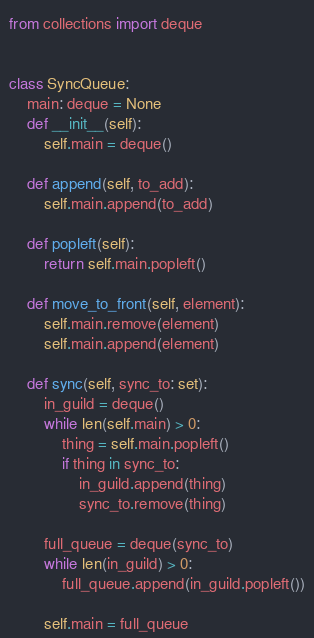Convert code to text. <code><loc_0><loc_0><loc_500><loc_500><_Python_>from collections import deque


class SyncQueue:
    main: deque = None
    def __init__(self):
        self.main = deque()

    def append(self, to_add):
        self.main.append(to_add)

    def popleft(self):
        return self.main.popleft()

    def move_to_front(self, element):
        self.main.remove(element)
        self.main.append(element)

    def sync(self, sync_to: set):
        in_guild = deque()
        while len(self.main) > 0:
            thing = self.main.popleft()
            if thing in sync_to:
                in_guild.append(thing)
                sync_to.remove(thing)

        full_queue = deque(sync_to)
        while len(in_guild) > 0:
            full_queue.append(in_guild.popleft())

        self.main = full_queue
</code> 